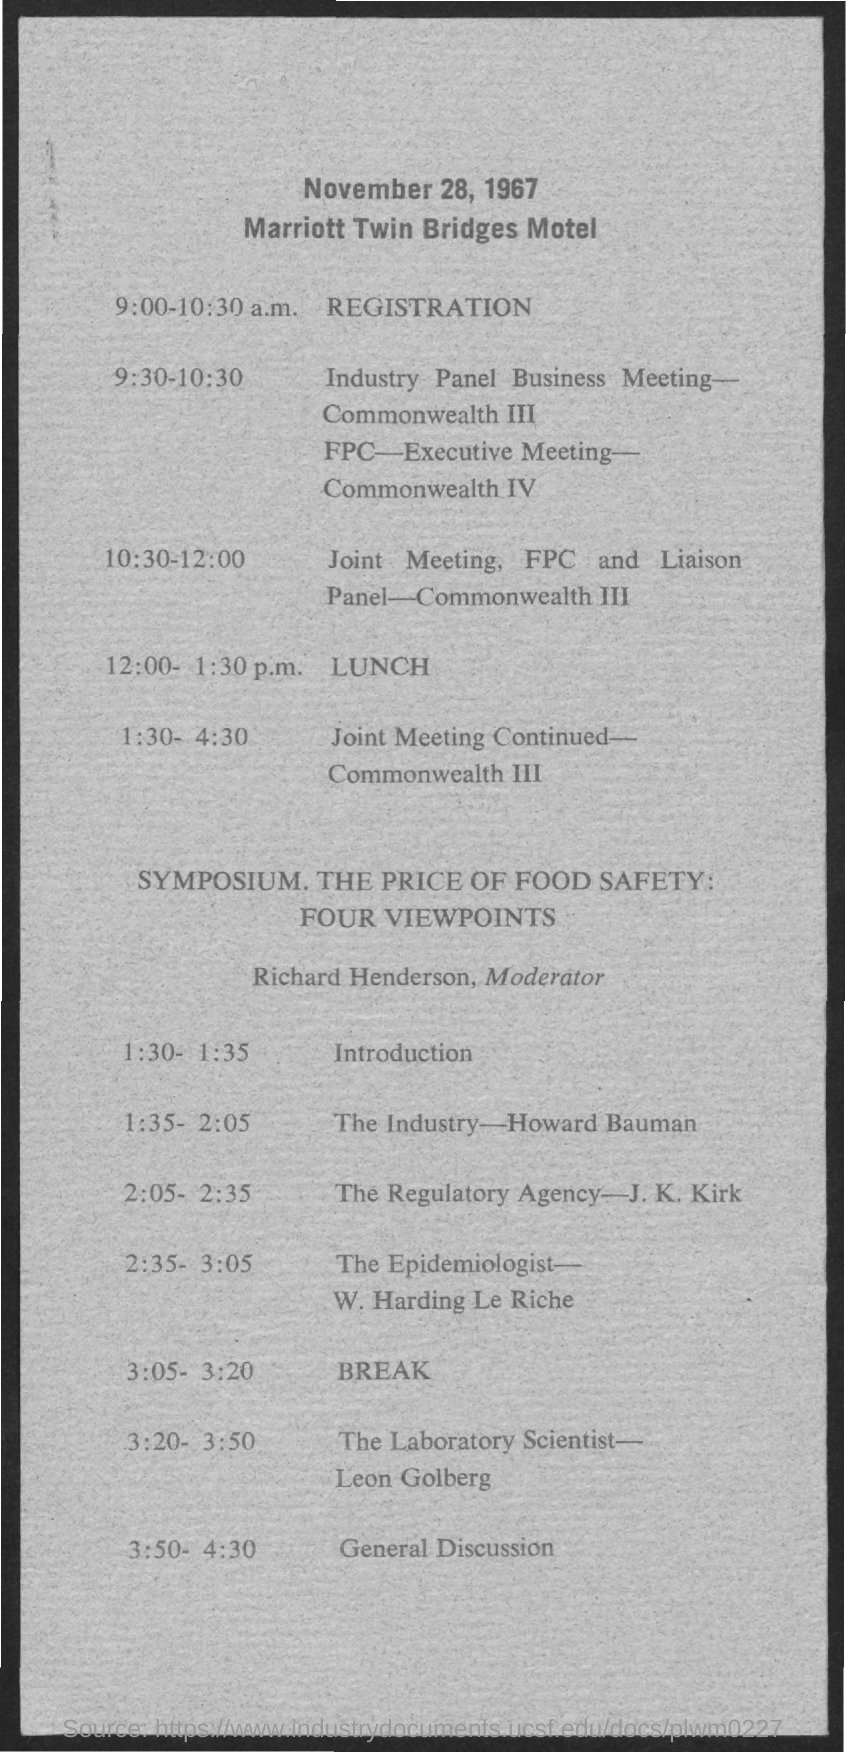Highlight a few significant elements in this photo. The Marriott Twin Bridges Motel is the name of a motel. 